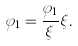Convert formula to latex. <formula><loc_0><loc_0><loc_500><loc_500>\varphi _ { 1 } = \frac { \varphi _ { 1 } } { \xi } \xi .</formula> 